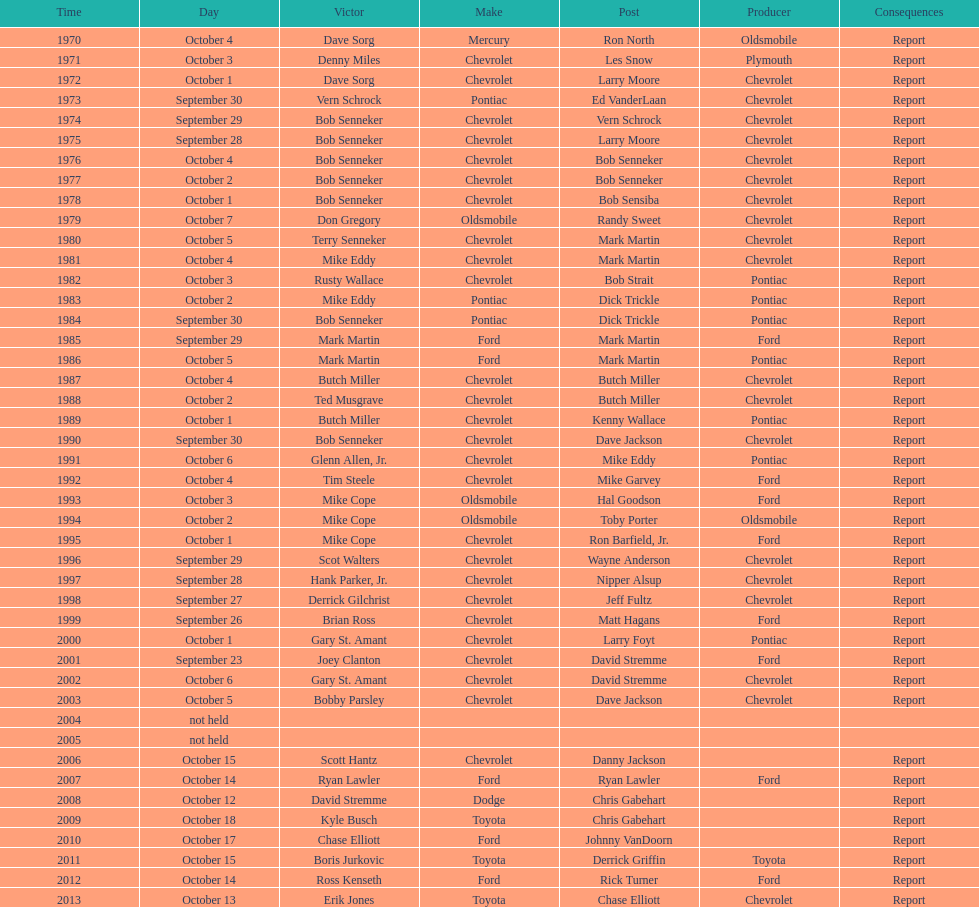Which month held the most winchester 400 races? October. 